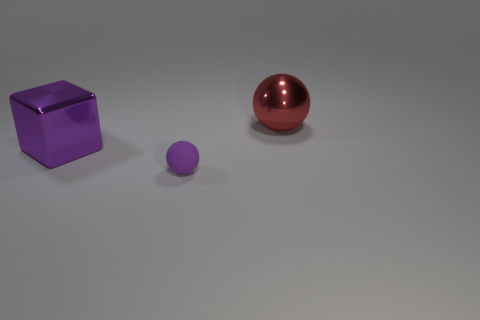What textures do the objects in the image appear to have? The objects in the image exhibit different textures: the larger sphere has a glossy, reflective surface suggestive of a polished material, possibly metal. The cube also has a reflective surface with a smooth texture, indicative of a metallic or plastic material. The smaller sphere appears to have a matte finish, indicating a non-reflective surface which could be indicative of a rubber or a non-shiny plastic material. 